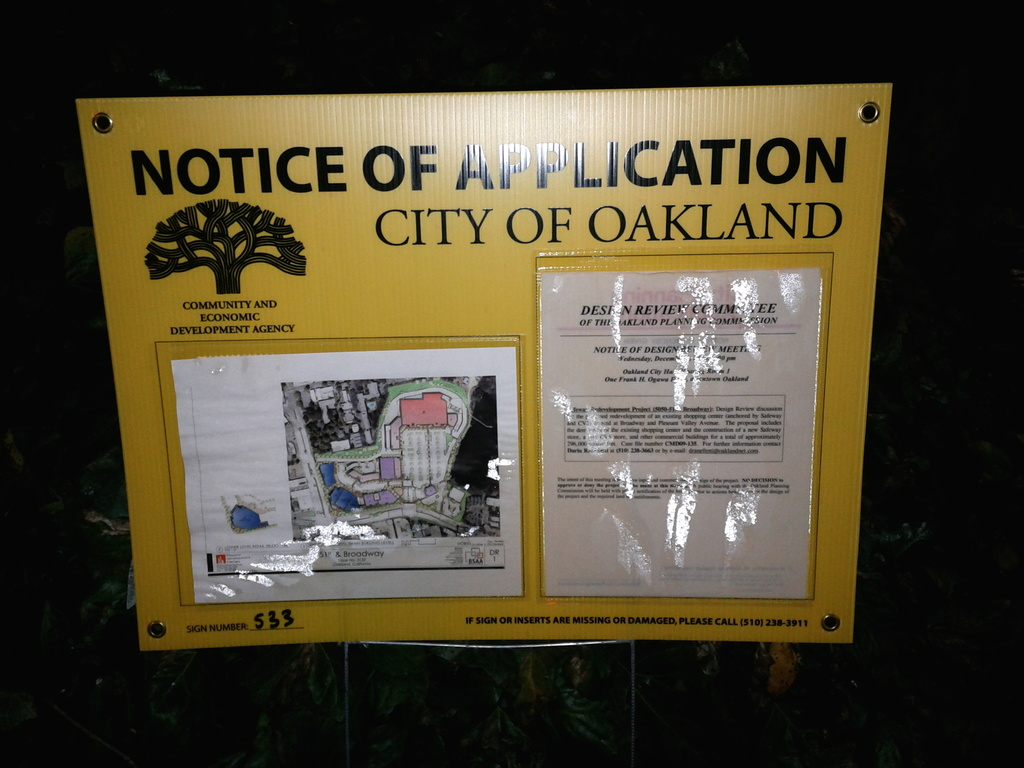Can you tell me more about the location mentioned on the map in this sign? The map on the sign details a section of downtown Oakland, highlighting the proposed development area near Broadway Street. The map is not detailed enough to provide specific addresses, but it indicates a significant urban area that could be transformed by the development plan. 